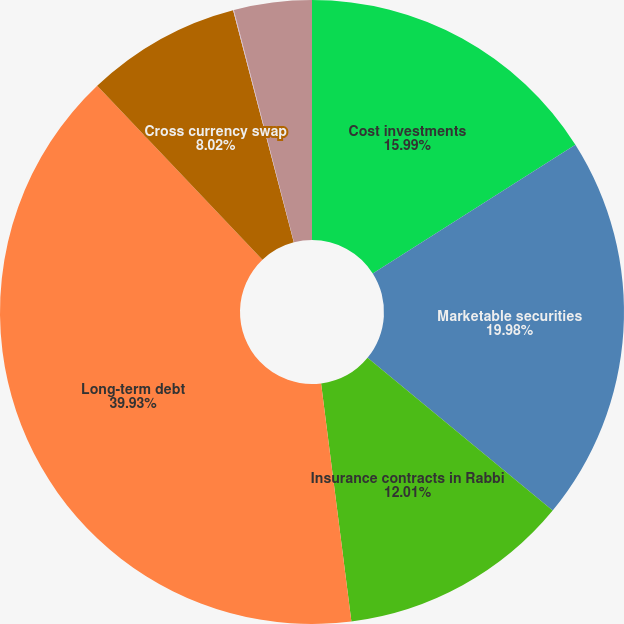Convert chart. <chart><loc_0><loc_0><loc_500><loc_500><pie_chart><fcel>Cost investments<fcel>Marketable securities<fcel>Insurance contracts in Rabbi<fcel>Long-term debt<fcel>Cross currency swap<fcel>Interest rate swap<fcel>Foreign currency forward<nl><fcel>16.0%<fcel>19.99%<fcel>12.01%<fcel>39.94%<fcel>8.02%<fcel>0.04%<fcel>4.03%<nl></chart> 